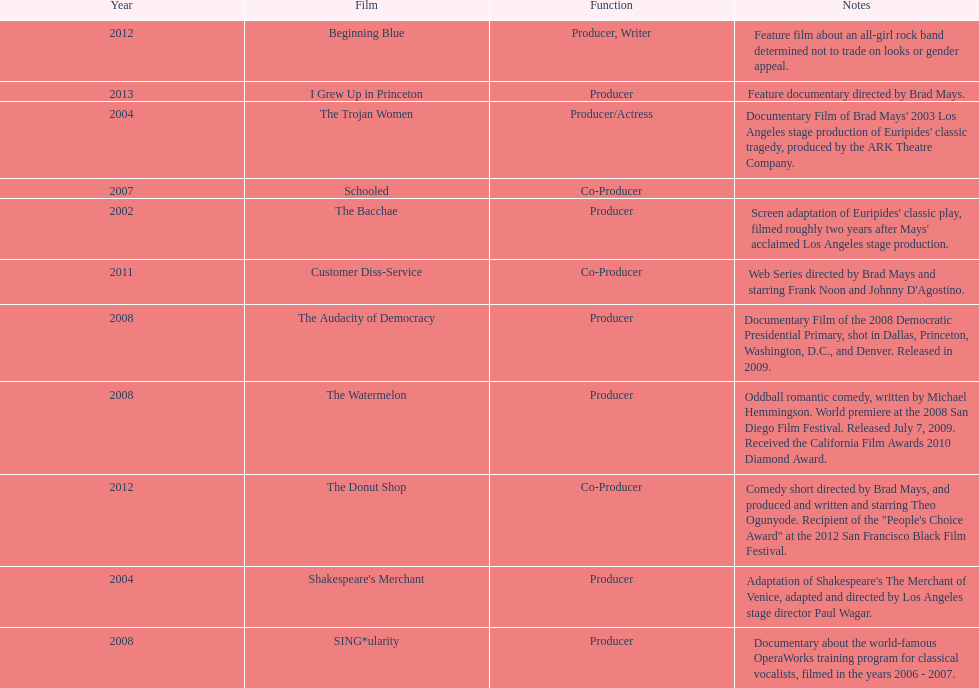How many films did ms. starfelt produce after 2010? 4. Could you help me parse every detail presented in this table? {'header': ['Year', 'Film', 'Function', 'Notes'], 'rows': [['2012', 'Beginning Blue', 'Producer, Writer', 'Feature film about an all-girl rock band determined not to trade on looks or gender appeal.'], ['2013', 'I Grew Up in Princeton', 'Producer', 'Feature documentary directed by Brad Mays.'], ['2004', 'The Trojan Women', 'Producer/Actress', "Documentary Film of Brad Mays' 2003 Los Angeles stage production of Euripides' classic tragedy, produced by the ARK Theatre Company."], ['2007', 'Schooled', 'Co-Producer', ''], ['2002', 'The Bacchae', 'Producer', "Screen adaptation of Euripides' classic play, filmed roughly two years after Mays' acclaimed Los Angeles stage production."], ['2011', 'Customer Diss-Service', 'Co-Producer', "Web Series directed by Brad Mays and starring Frank Noon and Johnny D'Agostino."], ['2008', 'The Audacity of Democracy', 'Producer', 'Documentary Film of the 2008 Democratic Presidential Primary, shot in Dallas, Princeton, Washington, D.C., and Denver. Released in 2009.'], ['2008', 'The Watermelon', 'Producer', 'Oddball romantic comedy, written by Michael Hemmingson. World premiere at the 2008 San Diego Film Festival. Released July 7, 2009. Received the California Film Awards 2010 Diamond Award.'], ['2012', 'The Donut Shop', 'Co-Producer', 'Comedy short directed by Brad Mays, and produced and written and starring Theo Ogunyode. Recipient of the "People\'s Choice Award" at the 2012 San Francisco Black Film Festival.'], ['2004', "Shakespeare's Merchant", 'Producer', "Adaptation of Shakespeare's The Merchant of Venice, adapted and directed by Los Angeles stage director Paul Wagar."], ['2008', 'SING*ularity', 'Producer', 'Documentary about the world-famous OperaWorks training program for classical vocalists, filmed in the years 2006 - 2007.']]} 